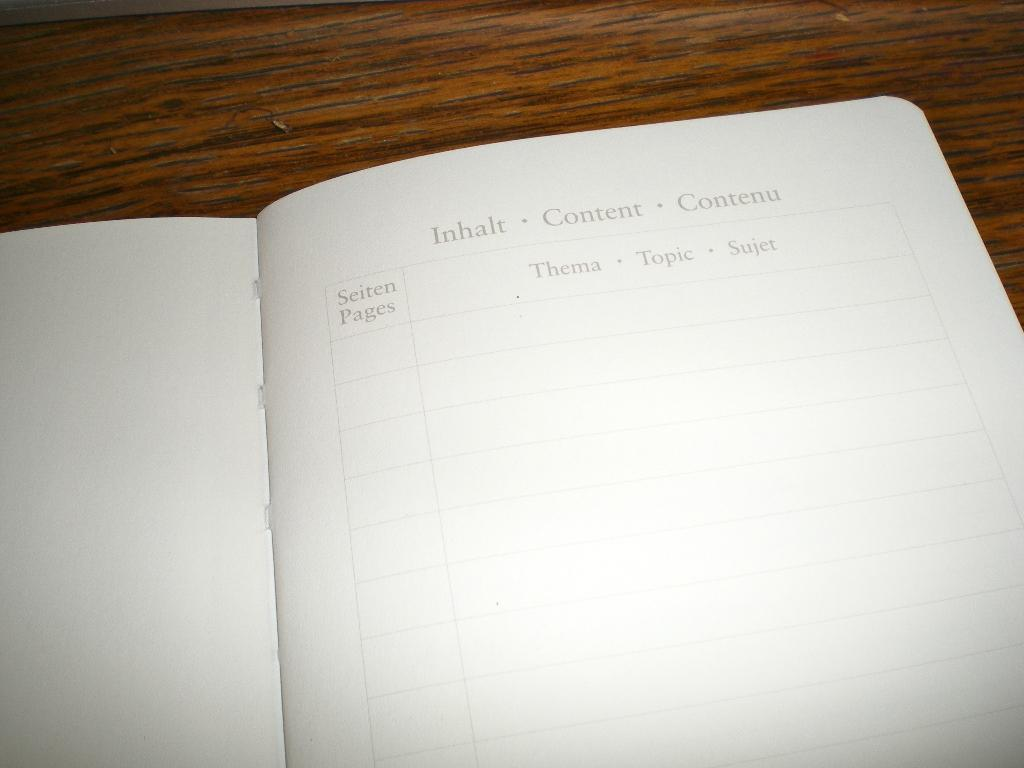<image>
Present a compact description of the photo's key features. A book is opened to a blank page titled Content. 